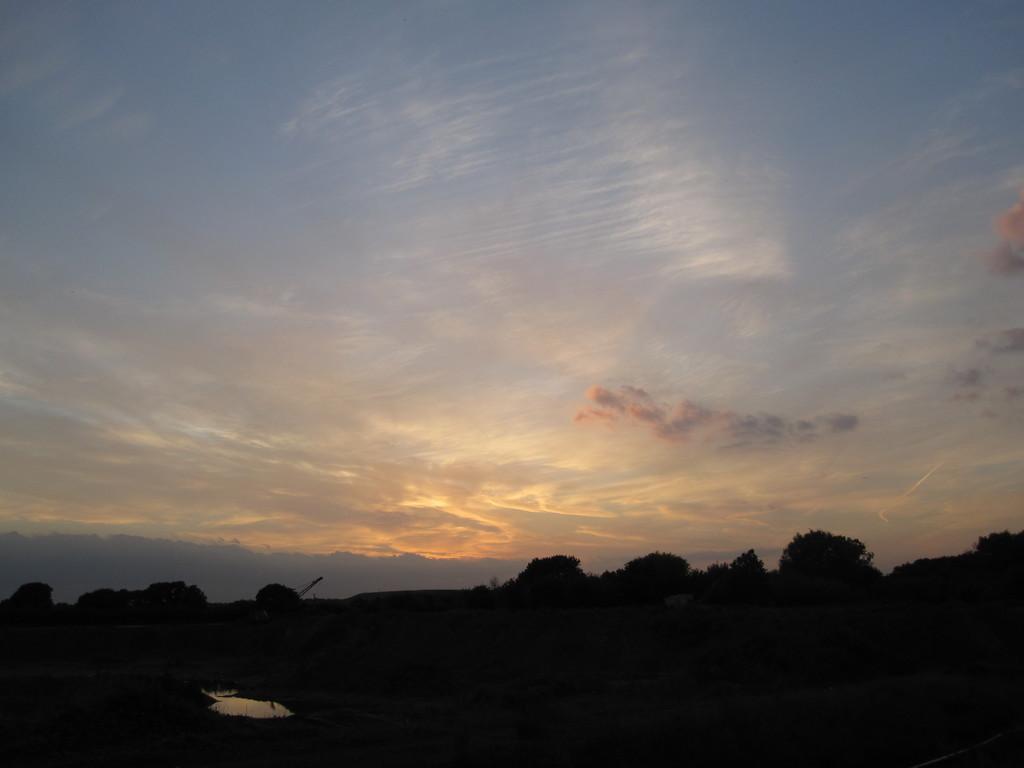In one or two sentences, can you explain what this image depicts? This picture consists of the sky at the top ,at the bottom I can see trees and this picture is taken during early morning. 